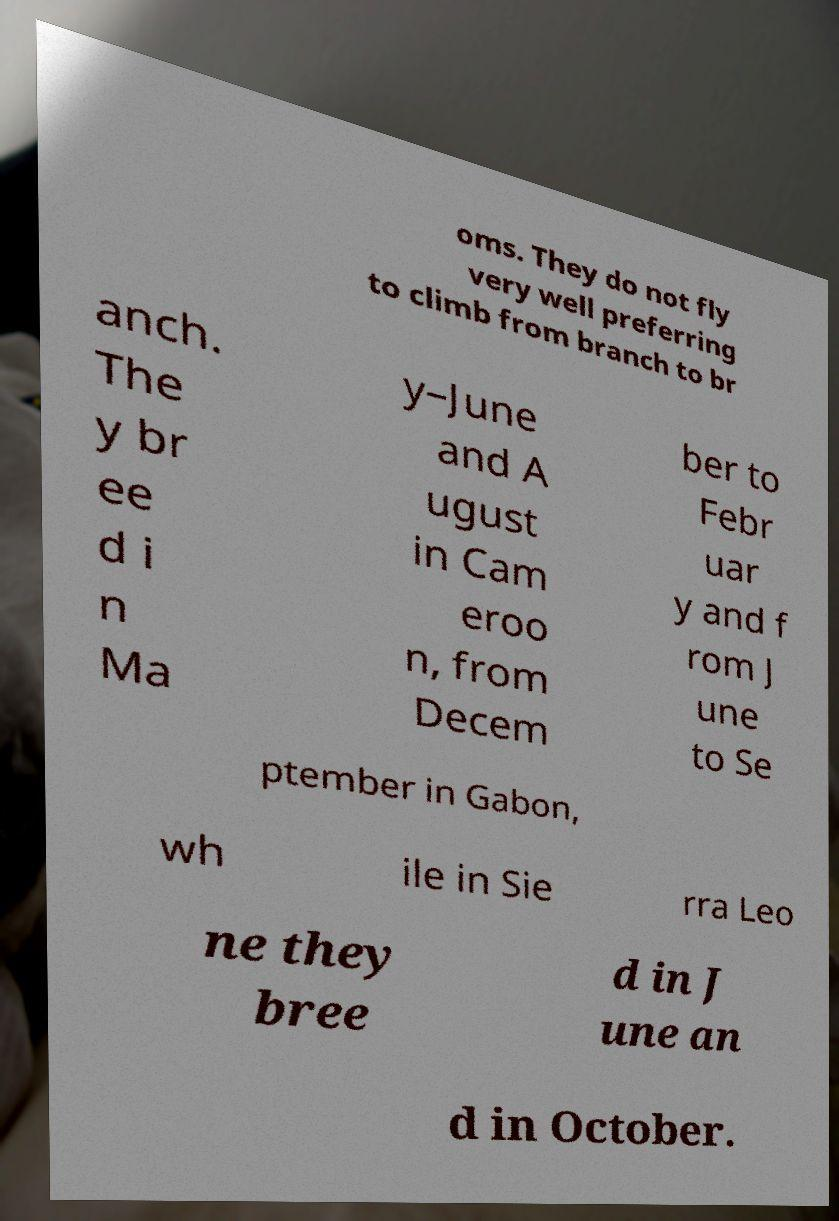For documentation purposes, I need the text within this image transcribed. Could you provide that? oms. They do not fly very well preferring to climb from branch to br anch. The y br ee d i n Ma y–June and A ugust in Cam eroo n, from Decem ber to Febr uar y and f rom J une to Se ptember in Gabon, wh ile in Sie rra Leo ne they bree d in J une an d in October. 